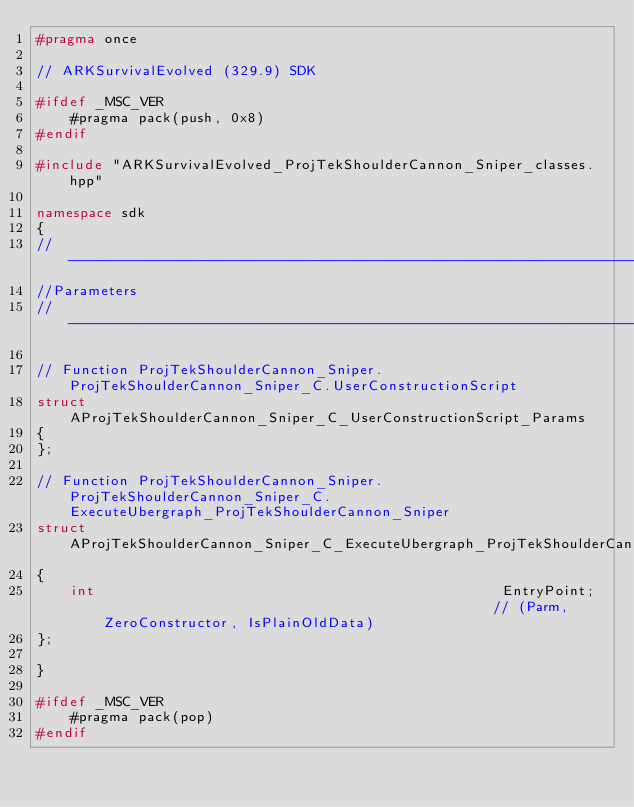<code> <loc_0><loc_0><loc_500><loc_500><_C++_>#pragma once

// ARKSurvivalEvolved (329.9) SDK

#ifdef _MSC_VER
	#pragma pack(push, 0x8)
#endif

#include "ARKSurvivalEvolved_ProjTekShoulderCannon_Sniper_classes.hpp"

namespace sdk
{
//---------------------------------------------------------------------------
//Parameters
//---------------------------------------------------------------------------

// Function ProjTekShoulderCannon_Sniper.ProjTekShoulderCannon_Sniper_C.UserConstructionScript
struct AProjTekShoulderCannon_Sniper_C_UserConstructionScript_Params
{
};

// Function ProjTekShoulderCannon_Sniper.ProjTekShoulderCannon_Sniper_C.ExecuteUbergraph_ProjTekShoulderCannon_Sniper
struct AProjTekShoulderCannon_Sniper_C_ExecuteUbergraph_ProjTekShoulderCannon_Sniper_Params
{
	int                                                EntryPoint;                                               // (Parm, ZeroConstructor, IsPlainOldData)
};

}

#ifdef _MSC_VER
	#pragma pack(pop)
#endif
</code> 